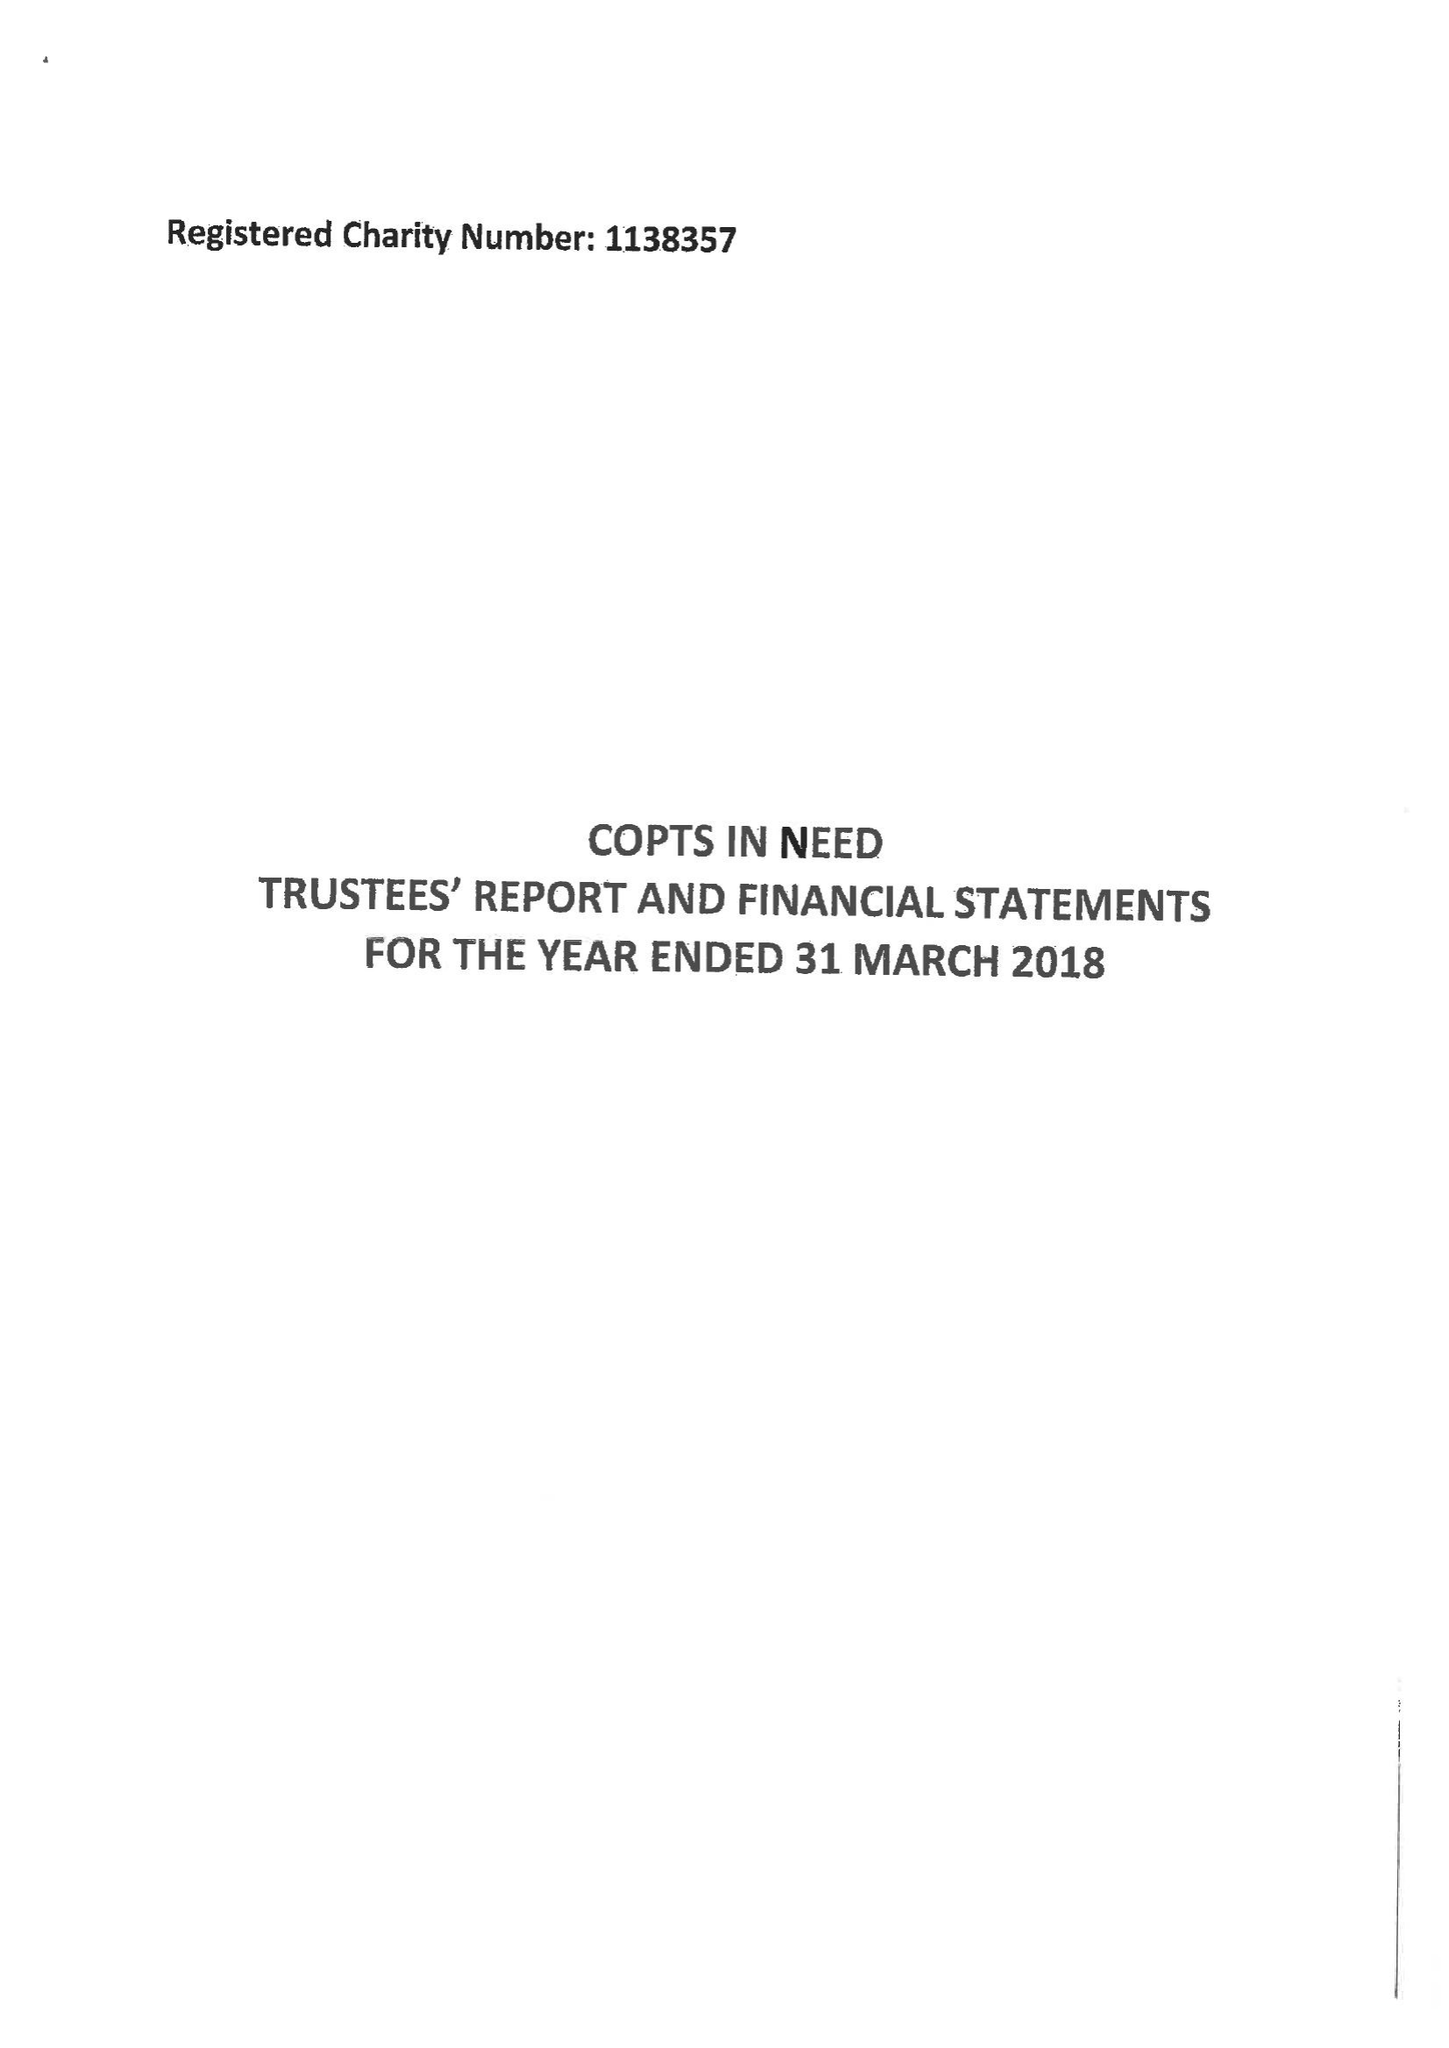What is the value for the charity_name?
Answer the question using a single word or phrase. Copts In Need 